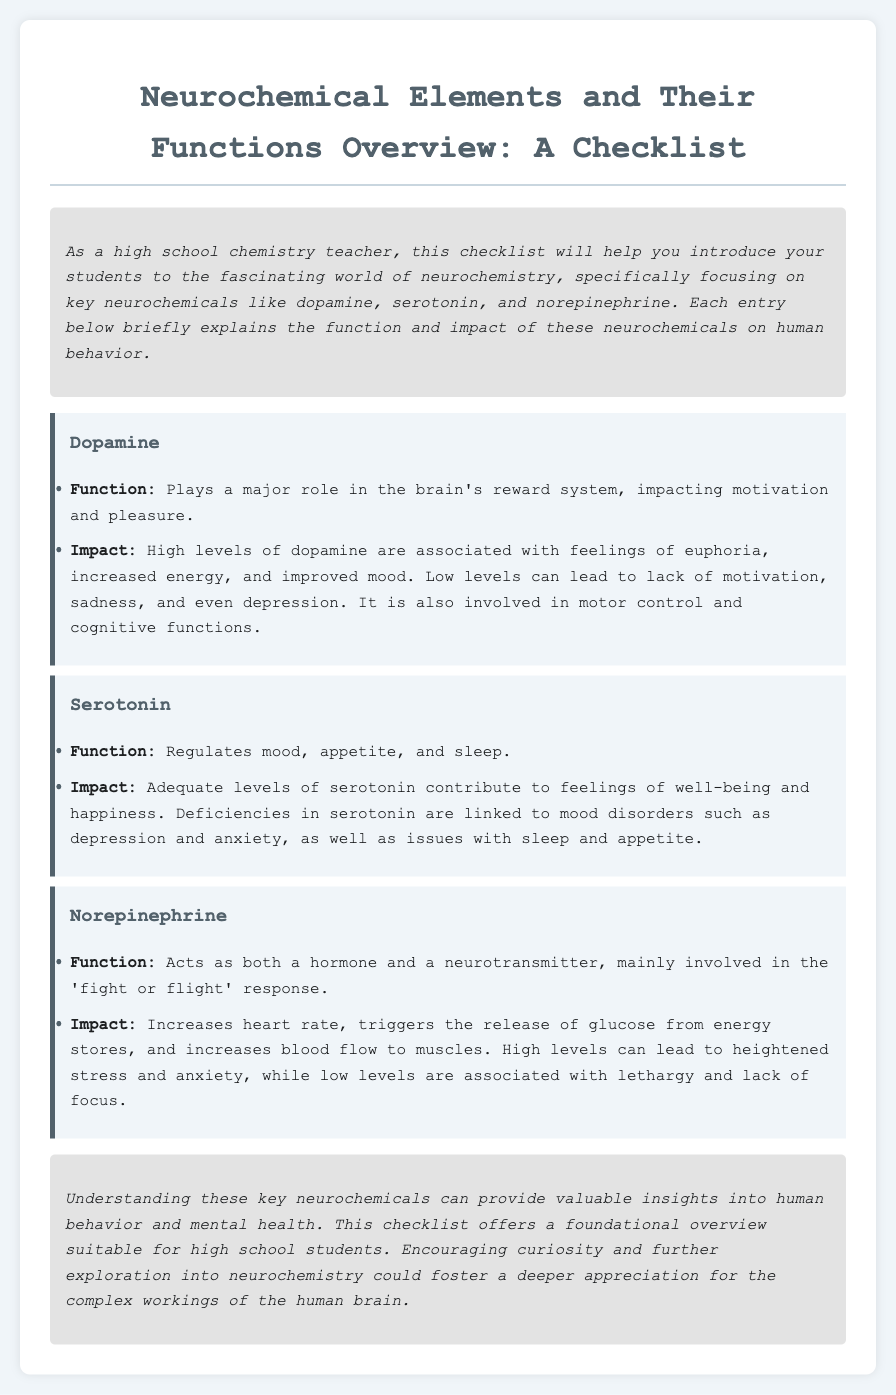What is the title of the document? The title of the document is presented at the top in a clear format, highlighting the main subject.
Answer: Neurochemical Elements and Their Functions Overview: A Checklist How many key neurochemicals are listed in the document? The document mentions three key neurochemicals in the checklist section.
Answer: 3 What is the primary function of dopamine? The function of dopamine is discussed in the first checklist entry, detailing its role in motivation and pleasure.
Answer: Plays a major role in the brain's reward system What impact does low serotonin levels have? The document indicates the consequences of low serotonin levels with respect to human behavior in the impact section for serotonin.
Answer: Linked to mood disorders such as depression and anxiety What response is norepinephrine primarily involved in? The function of norepinephrine is specified, focusing on its role in the fight or flight response.
Answer: Fight or flight response Which neurochemical is associated with feelings of euphoria? The impact of high dopamine levels is explicitly mentioned as contributing to feelings of euphoria.
Answer: Dopamine What type of document is this? The document is structured as a checklist, serving as a guideline for a specific subject matter.
Answer: Checklist What is the function of serotonin? The function is briefly described in the checklist entry related to serotonin.
Answer: Regulates mood, appetite, and sleep What does an increase in norepinephrine lead to? The impact of norepinephrine is discussed, including its effects on the body under stress.
Answer: Increases heart rate, triggers the release of glucose from energy stores 